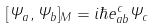<formula> <loc_0><loc_0><loc_500><loc_500>[ \Psi _ { a } , \Psi _ { b } ] _ { M } = i \hbar { e } _ { a b } ^ { c } \Psi _ { c }</formula> 